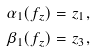<formula> <loc_0><loc_0><loc_500><loc_500>\alpha _ { 1 } ( f _ { z } ) & = z _ { 1 } , \\ \beta _ { 1 } ( f _ { z } ) & = z _ { 3 } ,</formula> 